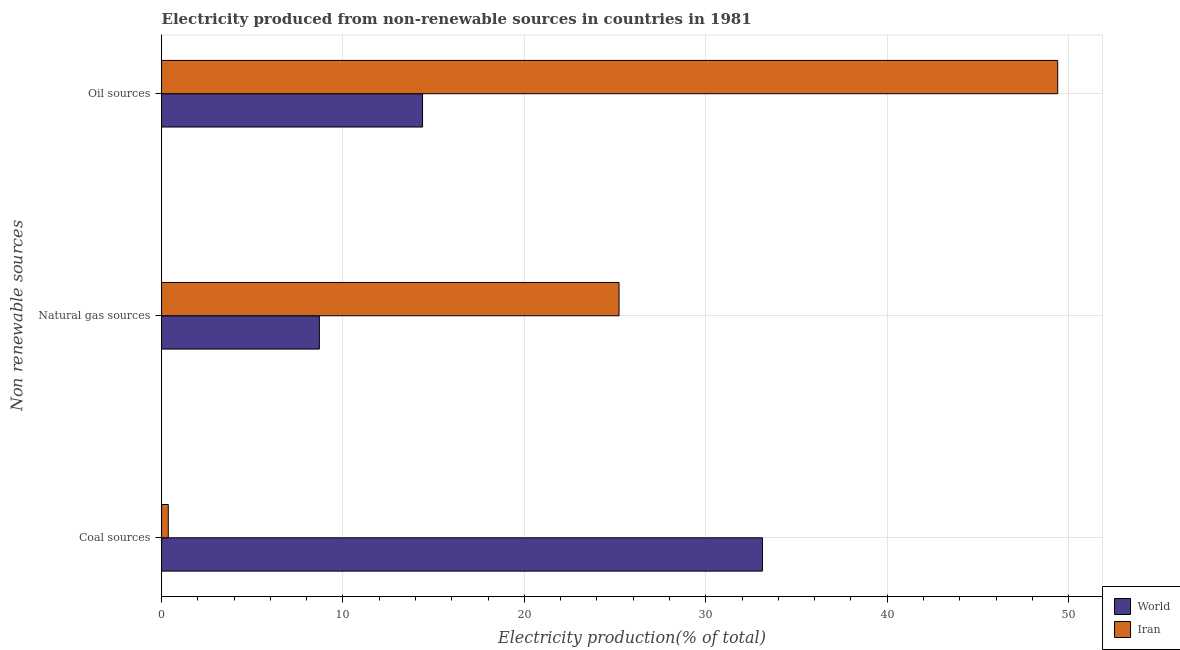How many groups of bars are there?
Ensure brevity in your answer.  3. Are the number of bars per tick equal to the number of legend labels?
Make the answer very short. Yes. Are the number of bars on each tick of the Y-axis equal?
Provide a succinct answer. Yes. How many bars are there on the 1st tick from the top?
Your response must be concise. 2. What is the label of the 2nd group of bars from the top?
Make the answer very short. Natural gas sources. What is the percentage of electricity produced by natural gas in World?
Give a very brief answer. 8.7. Across all countries, what is the maximum percentage of electricity produced by oil sources?
Your answer should be very brief. 49.4. Across all countries, what is the minimum percentage of electricity produced by coal?
Ensure brevity in your answer.  0.37. In which country was the percentage of electricity produced by coal minimum?
Make the answer very short. Iran. What is the total percentage of electricity produced by coal in the graph?
Offer a very short reply. 33.49. What is the difference between the percentage of electricity produced by coal in World and that in Iran?
Give a very brief answer. 32.76. What is the difference between the percentage of electricity produced by coal in World and the percentage of electricity produced by natural gas in Iran?
Provide a succinct answer. 7.91. What is the average percentage of electricity produced by natural gas per country?
Provide a short and direct response. 16.96. What is the difference between the percentage of electricity produced by natural gas and percentage of electricity produced by coal in World?
Keep it short and to the point. -24.43. In how many countries, is the percentage of electricity produced by natural gas greater than 22 %?
Your answer should be compact. 1. What is the ratio of the percentage of electricity produced by natural gas in World to that in Iran?
Give a very brief answer. 0.34. Is the percentage of electricity produced by oil sources in World less than that in Iran?
Make the answer very short. Yes. Is the difference between the percentage of electricity produced by natural gas in Iran and World greater than the difference between the percentage of electricity produced by coal in Iran and World?
Your response must be concise. Yes. What is the difference between the highest and the second highest percentage of electricity produced by oil sources?
Your response must be concise. 35.02. What is the difference between the highest and the lowest percentage of electricity produced by natural gas?
Give a very brief answer. 16.52. In how many countries, is the percentage of electricity produced by natural gas greater than the average percentage of electricity produced by natural gas taken over all countries?
Provide a succinct answer. 1. Is the sum of the percentage of electricity produced by natural gas in World and Iran greater than the maximum percentage of electricity produced by coal across all countries?
Offer a very short reply. Yes. What does the 2nd bar from the top in Natural gas sources represents?
Your response must be concise. World. What does the 2nd bar from the bottom in Coal sources represents?
Provide a short and direct response. Iran. Is it the case that in every country, the sum of the percentage of electricity produced by coal and percentage of electricity produced by natural gas is greater than the percentage of electricity produced by oil sources?
Ensure brevity in your answer.  No. How many bars are there?
Make the answer very short. 6. Does the graph contain grids?
Your answer should be very brief. Yes. How are the legend labels stacked?
Offer a terse response. Vertical. What is the title of the graph?
Keep it short and to the point. Electricity produced from non-renewable sources in countries in 1981. Does "Bosnia and Herzegovina" appear as one of the legend labels in the graph?
Offer a terse response. No. What is the label or title of the Y-axis?
Provide a short and direct response. Non renewable sources. What is the Electricity production(% of total) in World in Coal sources?
Your answer should be very brief. 33.12. What is the Electricity production(% of total) of Iran in Coal sources?
Offer a terse response. 0.37. What is the Electricity production(% of total) of World in Natural gas sources?
Give a very brief answer. 8.7. What is the Electricity production(% of total) of Iran in Natural gas sources?
Your answer should be compact. 25.22. What is the Electricity production(% of total) in World in Oil sources?
Offer a terse response. 14.39. What is the Electricity production(% of total) in Iran in Oil sources?
Your response must be concise. 49.4. Across all Non renewable sources, what is the maximum Electricity production(% of total) of World?
Your answer should be compact. 33.12. Across all Non renewable sources, what is the maximum Electricity production(% of total) in Iran?
Ensure brevity in your answer.  49.4. Across all Non renewable sources, what is the minimum Electricity production(% of total) of World?
Offer a terse response. 8.7. Across all Non renewable sources, what is the minimum Electricity production(% of total) in Iran?
Keep it short and to the point. 0.37. What is the total Electricity production(% of total) of World in the graph?
Keep it short and to the point. 56.21. What is the total Electricity production(% of total) of Iran in the graph?
Make the answer very short. 74.99. What is the difference between the Electricity production(% of total) of World in Coal sources and that in Natural gas sources?
Make the answer very short. 24.43. What is the difference between the Electricity production(% of total) of Iran in Coal sources and that in Natural gas sources?
Keep it short and to the point. -24.85. What is the difference between the Electricity production(% of total) in World in Coal sources and that in Oil sources?
Provide a succinct answer. 18.74. What is the difference between the Electricity production(% of total) of Iran in Coal sources and that in Oil sources?
Keep it short and to the point. -49.03. What is the difference between the Electricity production(% of total) in World in Natural gas sources and that in Oil sources?
Keep it short and to the point. -5.69. What is the difference between the Electricity production(% of total) of Iran in Natural gas sources and that in Oil sources?
Make the answer very short. -24.18. What is the difference between the Electricity production(% of total) of World in Coal sources and the Electricity production(% of total) of Iran in Natural gas sources?
Give a very brief answer. 7.91. What is the difference between the Electricity production(% of total) of World in Coal sources and the Electricity production(% of total) of Iran in Oil sources?
Give a very brief answer. -16.28. What is the difference between the Electricity production(% of total) in World in Natural gas sources and the Electricity production(% of total) in Iran in Oil sources?
Provide a succinct answer. -40.7. What is the average Electricity production(% of total) of World per Non renewable sources?
Your response must be concise. 18.74. What is the average Electricity production(% of total) in Iran per Non renewable sources?
Keep it short and to the point. 25. What is the difference between the Electricity production(% of total) of World and Electricity production(% of total) of Iran in Coal sources?
Ensure brevity in your answer.  32.76. What is the difference between the Electricity production(% of total) of World and Electricity production(% of total) of Iran in Natural gas sources?
Keep it short and to the point. -16.52. What is the difference between the Electricity production(% of total) of World and Electricity production(% of total) of Iran in Oil sources?
Give a very brief answer. -35.02. What is the ratio of the Electricity production(% of total) in World in Coal sources to that in Natural gas sources?
Offer a very short reply. 3.81. What is the ratio of the Electricity production(% of total) in Iran in Coal sources to that in Natural gas sources?
Offer a terse response. 0.01. What is the ratio of the Electricity production(% of total) in World in Coal sources to that in Oil sources?
Make the answer very short. 2.3. What is the ratio of the Electricity production(% of total) in Iran in Coal sources to that in Oil sources?
Make the answer very short. 0.01. What is the ratio of the Electricity production(% of total) of World in Natural gas sources to that in Oil sources?
Provide a short and direct response. 0.6. What is the ratio of the Electricity production(% of total) of Iran in Natural gas sources to that in Oil sources?
Make the answer very short. 0.51. What is the difference between the highest and the second highest Electricity production(% of total) of World?
Your answer should be compact. 18.74. What is the difference between the highest and the second highest Electricity production(% of total) in Iran?
Give a very brief answer. 24.18. What is the difference between the highest and the lowest Electricity production(% of total) of World?
Keep it short and to the point. 24.43. What is the difference between the highest and the lowest Electricity production(% of total) in Iran?
Offer a very short reply. 49.03. 